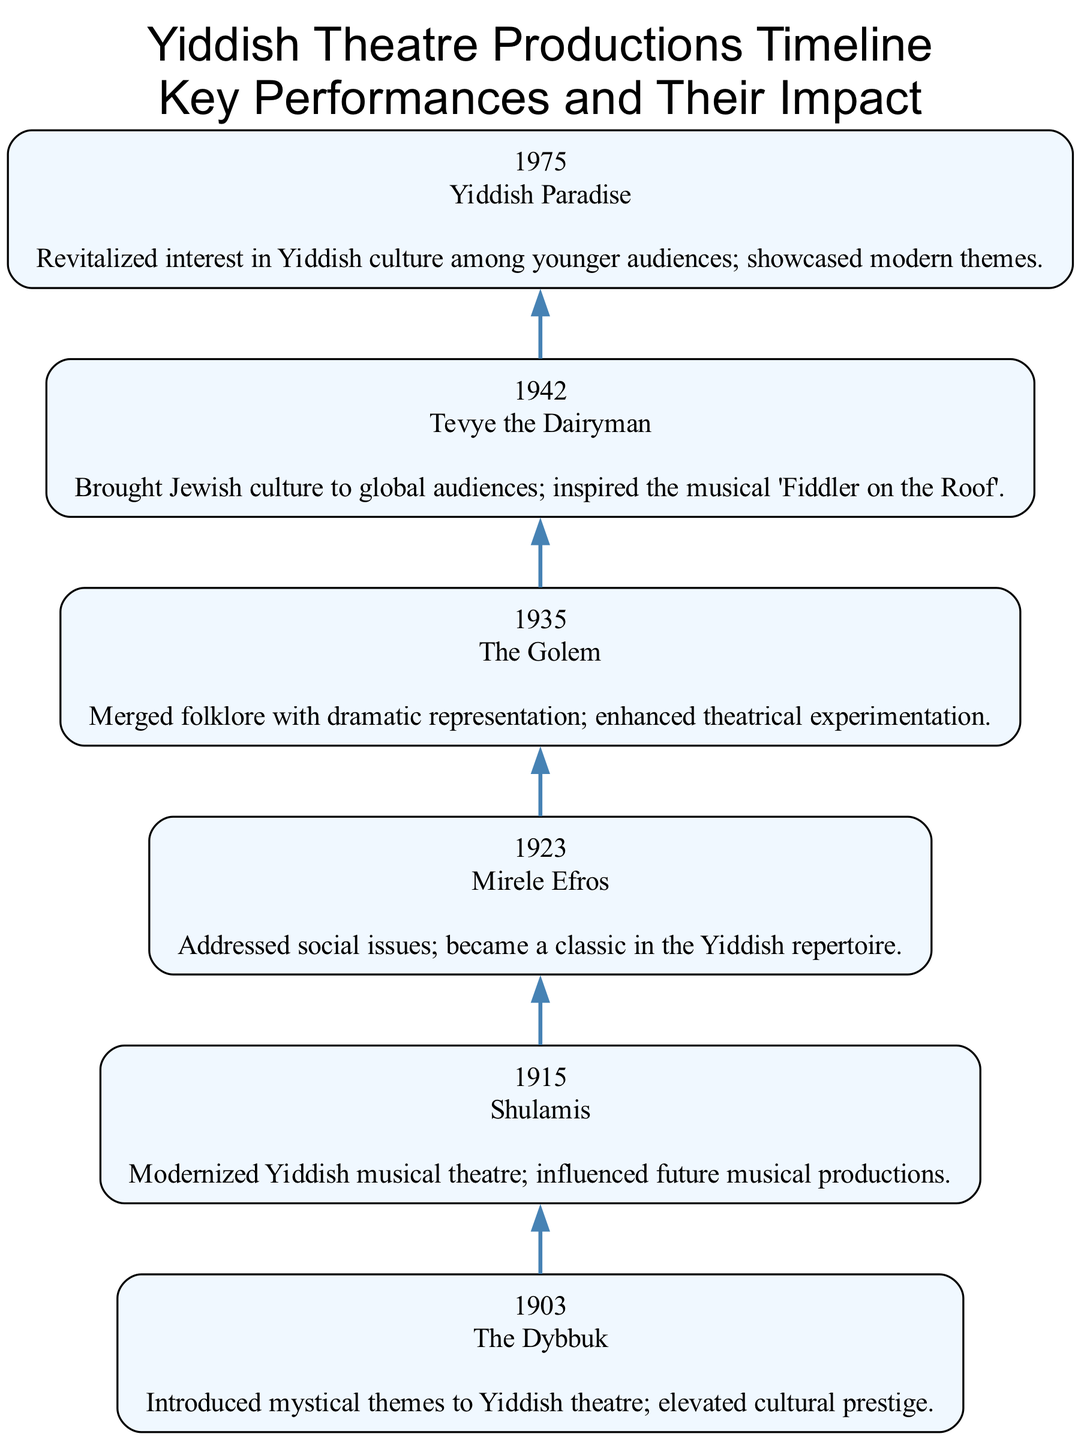What is the first performance listed in the diagram? The first performance is the one with the earliest year, which is 1903. Thus, the performance shown for that year is "The Dybbuk."
Answer: The Dybbuk How many performances are displayed in the diagram? To find the total number of performances, I count the nodes in the diagram. There are six performances represented for the years listed.
Answer: 6 What year did "Tevye the Dairyman" premiere? The year associated with "Tevye the Dairyman" is directly shown as 1942 in the node for that performance.
Answer: 1942 Which performance addressed social issues? Looking through the impacts of the performances, "Mirele Efros" specifically mentions addressing social issues, making it the answer to this question.
Answer: Mirele Efros What impact did "The Golem" have on theatre? The impact listed for "The Golem" describes how it merged folklore with dramatic representation and encouraged theatrical experimentation, which shows its influence on the art form.
Answer: Merged folklore with dramatic representation; enhanced theatrical experimentation Which production inspired the musical "Fiddler on the Roof"? The diagram indicates that "Tevye the Dairyman" was the production that inspired "Fiddler on the Roof," making this a straightforward reference in the impact of that performance.
Answer: Tevye the Dairyman What node comes immediately after "Shulamis"? The flow of the diagram connects "Shulamis," which is associated with the year 1915, to the node for the next production, "Mirele Efros," that appears in 1923, moving sequentially through the years.
Answer: Mirele Efros How many years separate the performances "The Dybbuk" and "Yiddish Paradise"? By looking at the years provided, "The Dybbuk" was in 1903 and "Yiddish Paradise" in 1975. Calculating the difference gives 1975 - 1903 = 72 years.
Answer: 72 years 